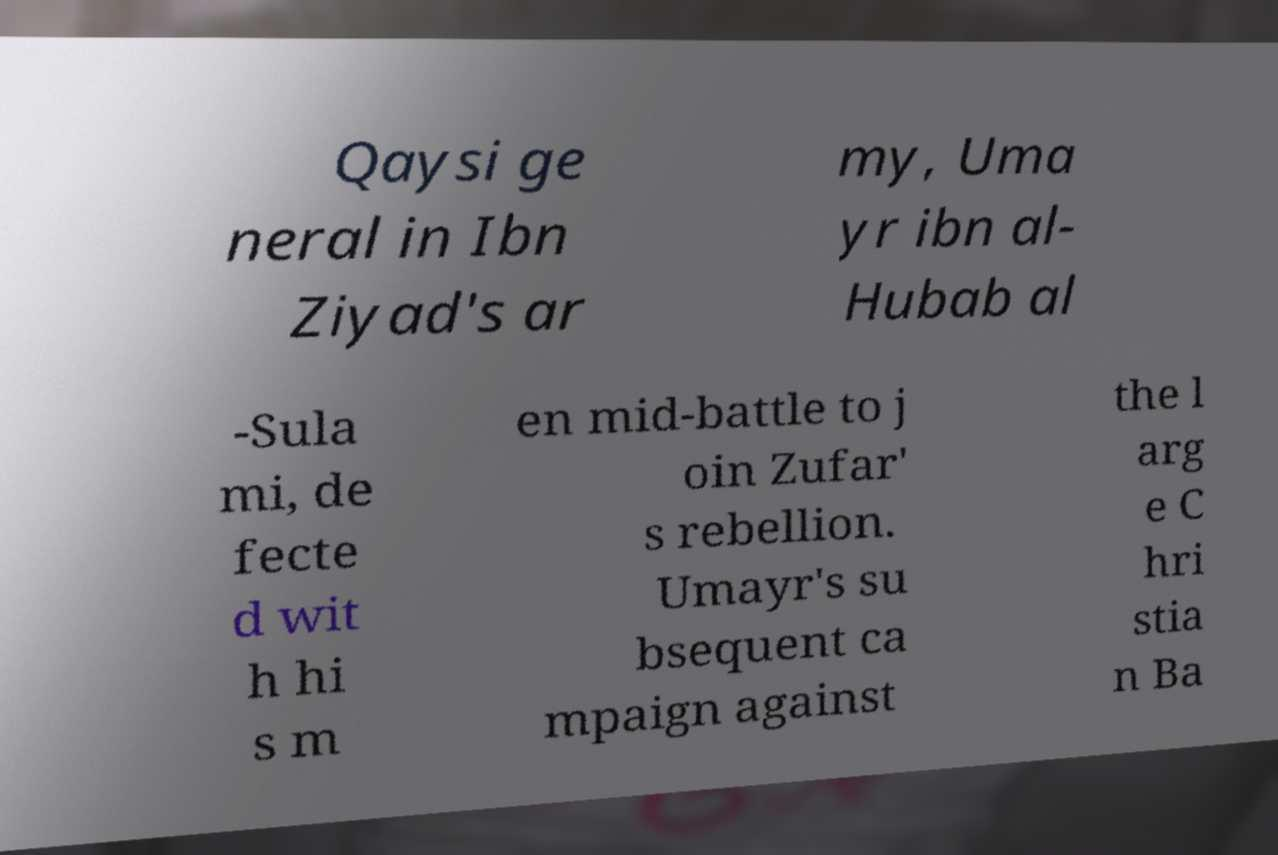Please identify and transcribe the text found in this image. Qaysi ge neral in Ibn Ziyad's ar my, Uma yr ibn al- Hubab al -Sula mi, de fecte d wit h hi s m en mid-battle to j oin Zufar' s rebellion. Umayr's su bsequent ca mpaign against the l arg e C hri stia n Ba 